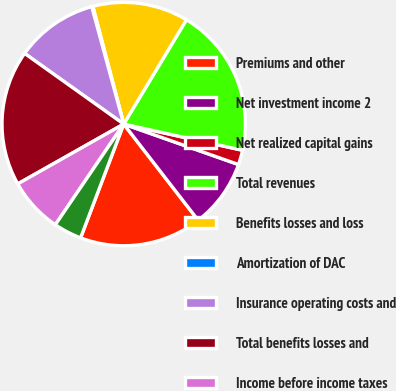<chart> <loc_0><loc_0><loc_500><loc_500><pie_chart><fcel>Premiums and other<fcel>Net investment income 2<fcel>Net realized capital gains<fcel>Total revenues<fcel>Benefits losses and loss<fcel>Amortization of DAC<fcel>Insurance operating costs and<fcel>Total benefits losses and<fcel>Income before income taxes<fcel>Income tax expense 3<nl><fcel>16.25%<fcel>9.12%<fcel>1.94%<fcel>19.84%<fcel>12.7%<fcel>0.15%<fcel>10.91%<fcel>18.04%<fcel>7.32%<fcel>3.73%<nl></chart> 